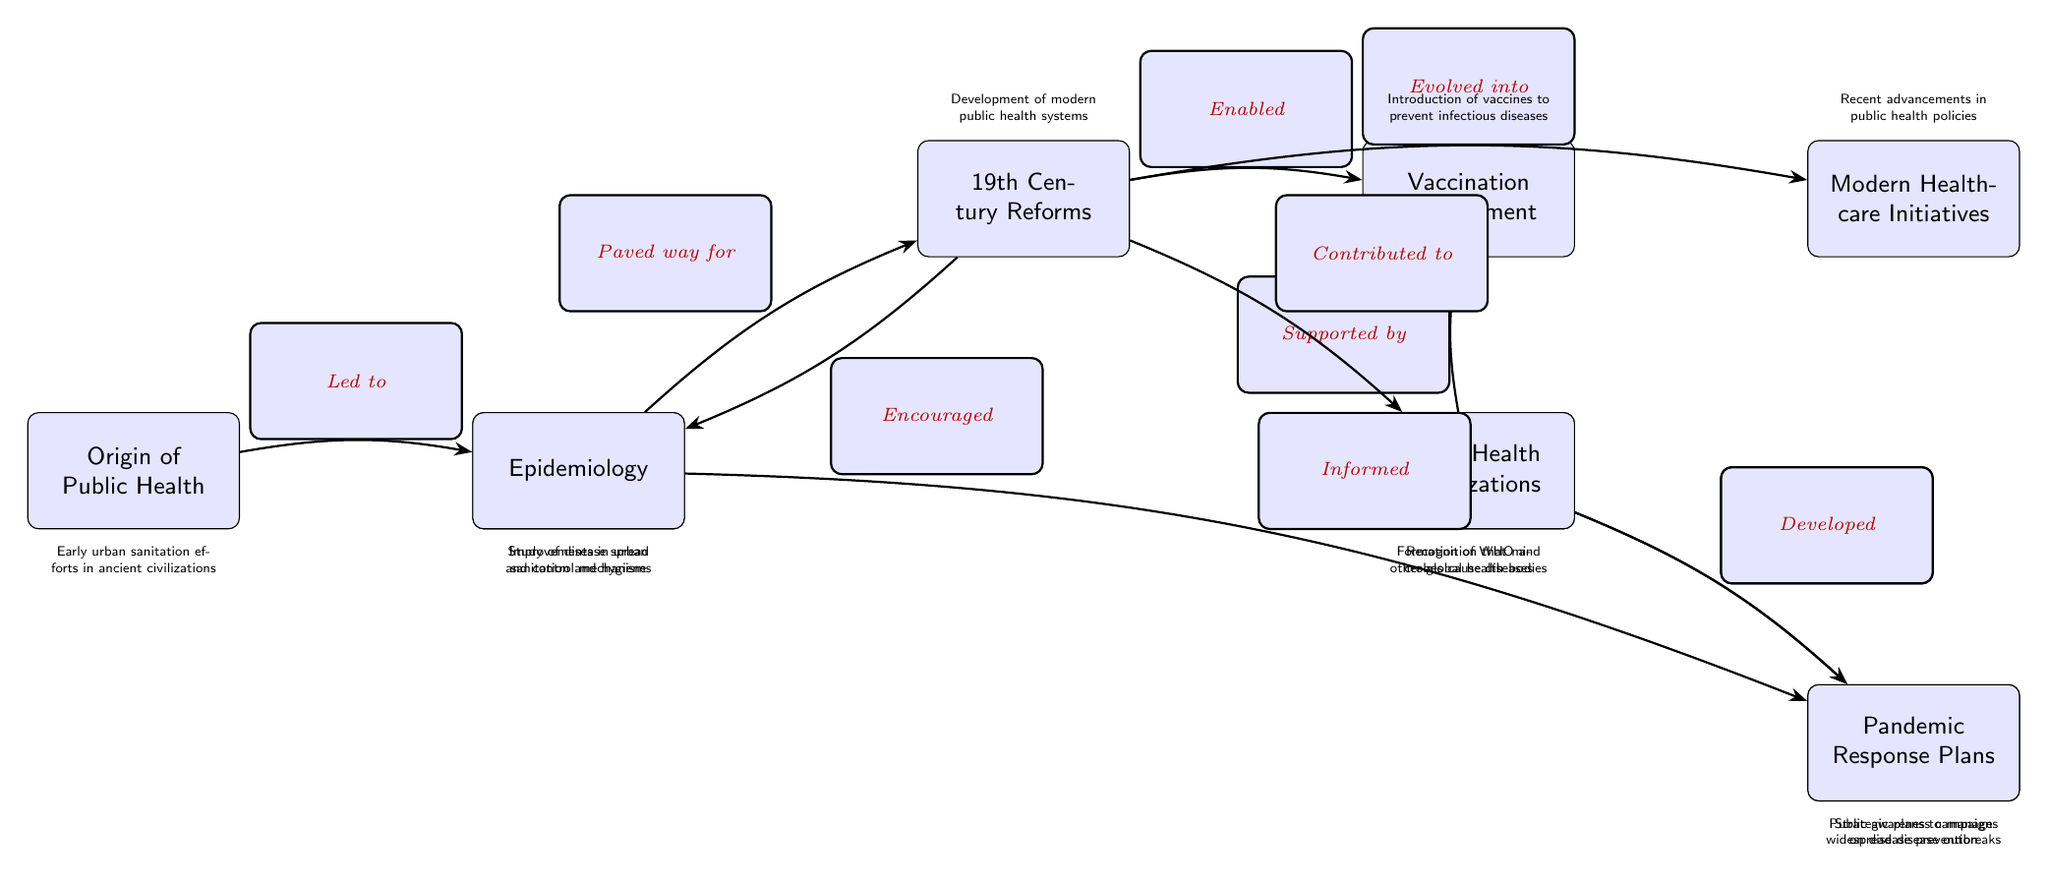What is the first node in the diagram? The first node is labeled "Origin of Public Health," indicating the starting point of the evolution of public health initiatives.
Answer: Origin of Public Health How many nodes are present in the diagram? By counting all the distinct labeled nodes, there are ten nodes illustrating the progression of public health initiatives and disease control.
Answer: 10 What relationship is indicated between the "Sanitary Revolution" and "19th Century Reforms"? The diagram states that the "Sanitary Revolution" paved the way for "19th Century Reforms," showing a direct causal relationship between these two initiatives.
Answer: Paved way for Which node is directly connected to "Germ Theory"? The diagram shows that "Germ Theory" is directly connected to "Vaccination Development," indicating the influence of germ theory on vaccine advancements.
Answer: Vaccination Development What is the last node in the diagram? The last node is labeled "Pandemic Response Plans," which reflects the culmination of modern public health strategies addressed in the diagram.
Answer: Pandemic Response Plans Which two nodes are connected by the phrase "Informed"? The phrase "Informed" connects the node "Epidemiology" to "Pandemic Response Plans," indicating that epidemiological studies inform how responses to pandemics are created.
Answer: Epidemiology and Pandemic Response Plans What node evolves from "19th Century Reforms"? The diagram indicates that "19th Century Reforms" evolved into "Modern Healthcare Initiatives," marking the transition from historical reforms to contemporary healthcare practices.
Answer: Modern Healthcare Initiatives How does "Germ Theory" support another node in the diagram? "Germ Theory" supports the node "Health Education," suggesting that knowledge about germs enhances public understanding and education on health matters.
Answer: Health Education What does the node "Global Health Organizations" develop? According to the diagram, "Global Health Organizations" are responsible for developing "Pandemic Response Plans," highlighting their role in coordinating responses to health crises.
Answer: Pandemic Response Plans 